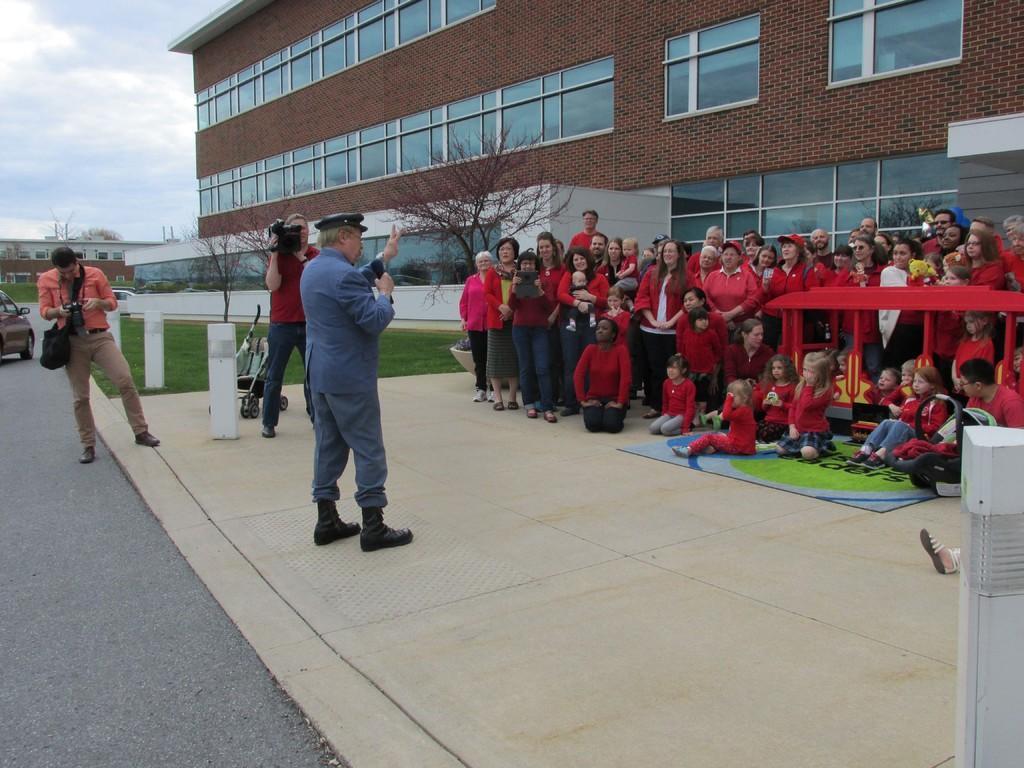How would you summarize this image in a sentence or two? On the right side of the image we can see group of persons on the floor. On the left side of the image we can see group of persons standing and vehicle on the road. At the bottom there is a road. In the background we can see buildings, trees, sky and clouds. 